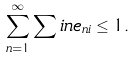<formula> <loc_0><loc_0><loc_500><loc_500>\sum _ { n = 1 } ^ { \infty } \sum i n e _ { n i } \leq 1 .</formula> 